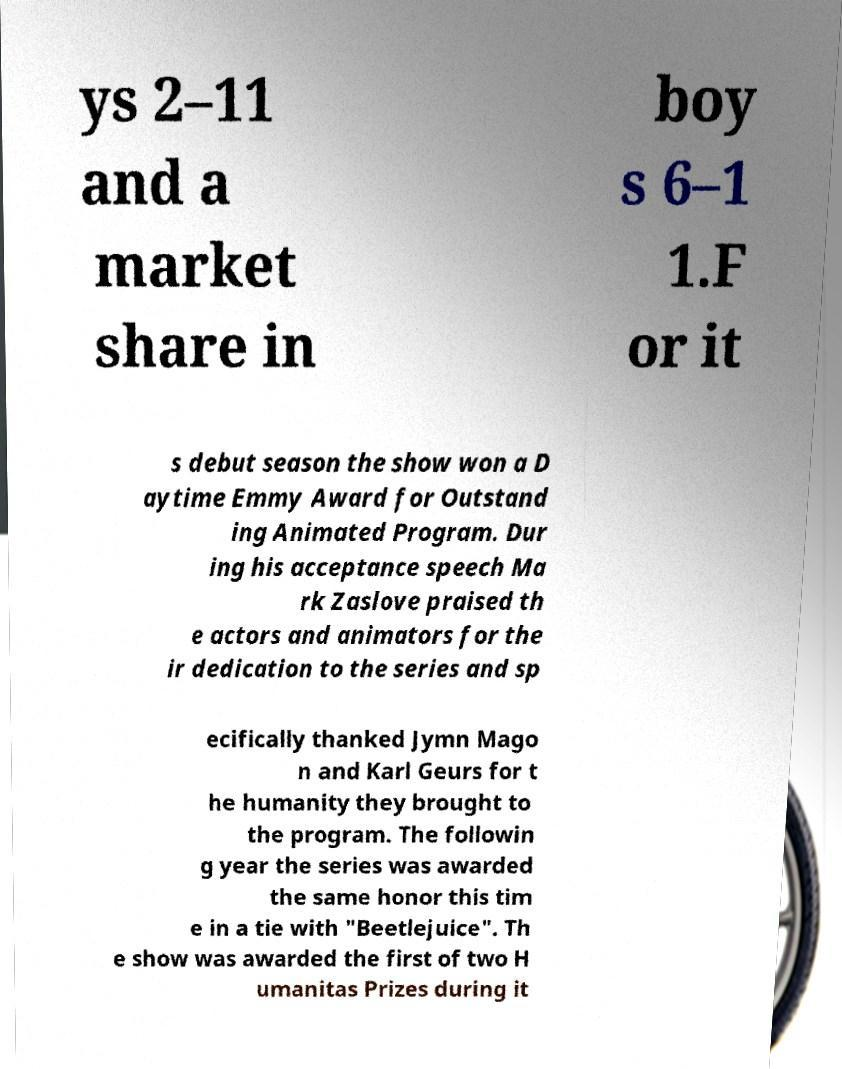Can you read and provide the text displayed in the image?This photo seems to have some interesting text. Can you extract and type it out for me? ys 2–11 and a market share in boy s 6–1 1.F or it s debut season the show won a D aytime Emmy Award for Outstand ing Animated Program. Dur ing his acceptance speech Ma rk Zaslove praised th e actors and animators for the ir dedication to the series and sp ecifically thanked Jymn Mago n and Karl Geurs for t he humanity they brought to the program. The followin g year the series was awarded the same honor this tim e in a tie with "Beetlejuice". Th e show was awarded the first of two H umanitas Prizes during it 